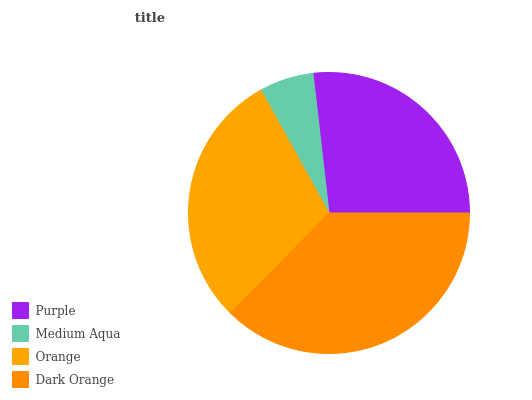Is Medium Aqua the minimum?
Answer yes or no. Yes. Is Dark Orange the maximum?
Answer yes or no. Yes. Is Orange the minimum?
Answer yes or no. No. Is Orange the maximum?
Answer yes or no. No. Is Orange greater than Medium Aqua?
Answer yes or no. Yes. Is Medium Aqua less than Orange?
Answer yes or no. Yes. Is Medium Aqua greater than Orange?
Answer yes or no. No. Is Orange less than Medium Aqua?
Answer yes or no. No. Is Orange the high median?
Answer yes or no. Yes. Is Purple the low median?
Answer yes or no. Yes. Is Medium Aqua the high median?
Answer yes or no. No. Is Orange the low median?
Answer yes or no. No. 